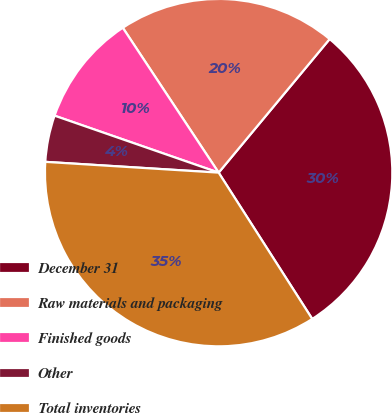<chart> <loc_0><loc_0><loc_500><loc_500><pie_chart><fcel>December 31<fcel>Raw materials and packaging<fcel>Finished goods<fcel>Other<fcel>Total inventories<nl><fcel>29.91%<fcel>20.34%<fcel>10.38%<fcel>4.33%<fcel>35.05%<nl></chart> 